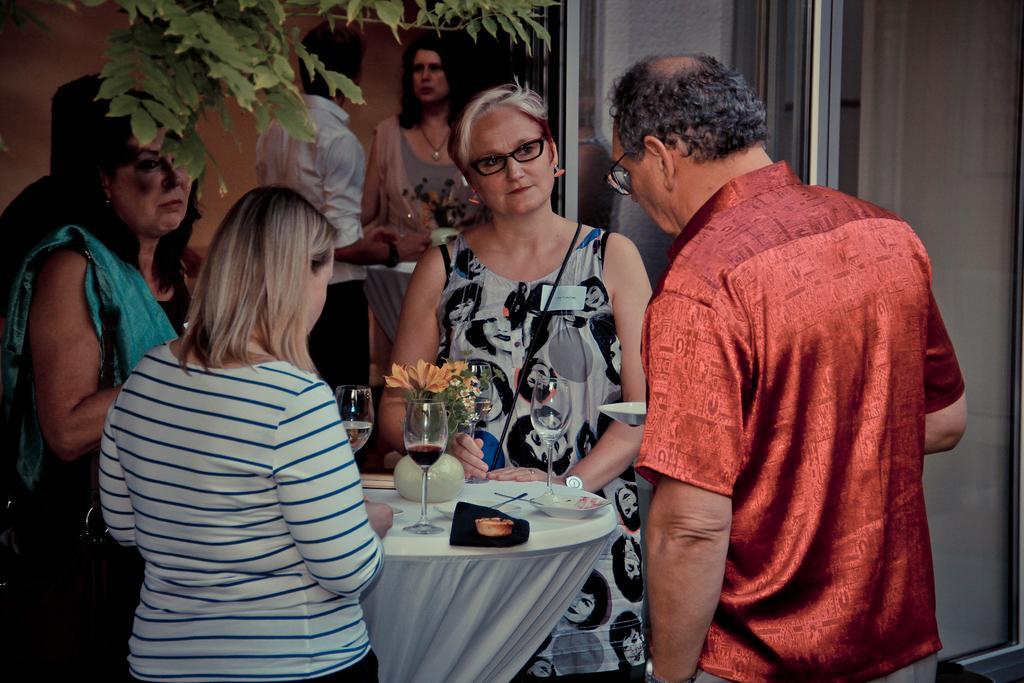Could you give a brief overview of what you see in this image? This image consists of three women and a man. In the middle, there is a table on which there are glasses and plates. To the left, there is a tree. In the background, there are walls along with the doors. 